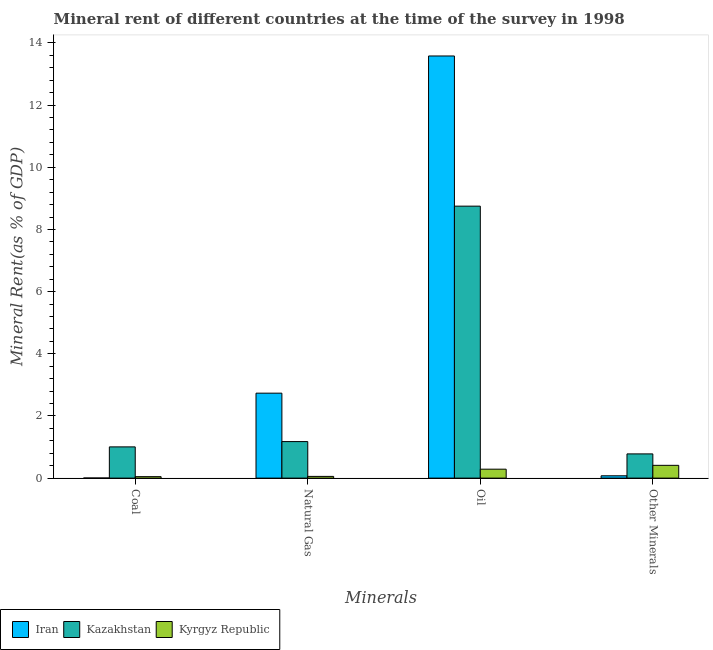How many different coloured bars are there?
Provide a succinct answer. 3. How many groups of bars are there?
Keep it short and to the point. 4. Are the number of bars on each tick of the X-axis equal?
Give a very brief answer. Yes. What is the label of the 1st group of bars from the left?
Make the answer very short. Coal. What is the  rent of other minerals in Kyrgyz Republic?
Offer a terse response. 0.41. Across all countries, what is the maximum natural gas rent?
Offer a very short reply. 2.73. Across all countries, what is the minimum natural gas rent?
Ensure brevity in your answer.  0.06. In which country was the oil rent maximum?
Your answer should be compact. Iran. In which country was the coal rent minimum?
Make the answer very short. Iran. What is the total natural gas rent in the graph?
Your answer should be compact. 3.96. What is the difference between the coal rent in Kazakhstan and that in Kyrgyz Republic?
Offer a very short reply. 0.96. What is the difference between the natural gas rent in Kyrgyz Republic and the coal rent in Iran?
Offer a very short reply. 0.05. What is the average  rent of other minerals per country?
Provide a short and direct response. 0.42. What is the difference between the natural gas rent and coal rent in Iran?
Your answer should be compact. 2.73. In how many countries, is the coal rent greater than 6 %?
Give a very brief answer. 0. What is the ratio of the oil rent in Kazakhstan to that in Iran?
Ensure brevity in your answer.  0.64. Is the difference between the coal rent in Kyrgyz Republic and Kazakhstan greater than the difference between the  rent of other minerals in Kyrgyz Republic and Kazakhstan?
Offer a very short reply. No. What is the difference between the highest and the second highest oil rent?
Your answer should be compact. 4.83. What is the difference between the highest and the lowest  rent of other minerals?
Your response must be concise. 0.7. Is it the case that in every country, the sum of the oil rent and natural gas rent is greater than the sum of  rent of other minerals and coal rent?
Give a very brief answer. No. What does the 1st bar from the left in Coal represents?
Offer a very short reply. Iran. What does the 3rd bar from the right in Oil represents?
Give a very brief answer. Iran. How many bars are there?
Offer a very short reply. 12. Are all the bars in the graph horizontal?
Ensure brevity in your answer.  No. What is the difference between two consecutive major ticks on the Y-axis?
Offer a terse response. 2. Are the values on the major ticks of Y-axis written in scientific E-notation?
Your response must be concise. No. Where does the legend appear in the graph?
Provide a short and direct response. Bottom left. How many legend labels are there?
Provide a succinct answer. 3. What is the title of the graph?
Offer a terse response. Mineral rent of different countries at the time of the survey in 1998. What is the label or title of the X-axis?
Your answer should be compact. Minerals. What is the label or title of the Y-axis?
Ensure brevity in your answer.  Mineral Rent(as % of GDP). What is the Mineral Rent(as % of GDP) in Iran in Coal?
Provide a short and direct response. 0. What is the Mineral Rent(as % of GDP) of Kazakhstan in Coal?
Ensure brevity in your answer.  1.01. What is the Mineral Rent(as % of GDP) in Kyrgyz Republic in Coal?
Your answer should be very brief. 0.05. What is the Mineral Rent(as % of GDP) of Iran in Natural Gas?
Offer a terse response. 2.73. What is the Mineral Rent(as % of GDP) in Kazakhstan in Natural Gas?
Keep it short and to the point. 1.18. What is the Mineral Rent(as % of GDP) in Kyrgyz Republic in Natural Gas?
Offer a very short reply. 0.06. What is the Mineral Rent(as % of GDP) of Iran in Oil?
Offer a very short reply. 13.58. What is the Mineral Rent(as % of GDP) in Kazakhstan in Oil?
Make the answer very short. 8.75. What is the Mineral Rent(as % of GDP) in Kyrgyz Republic in Oil?
Keep it short and to the point. 0.29. What is the Mineral Rent(as % of GDP) in Iran in Other Minerals?
Provide a succinct answer. 0.07. What is the Mineral Rent(as % of GDP) in Kazakhstan in Other Minerals?
Offer a terse response. 0.78. What is the Mineral Rent(as % of GDP) in Kyrgyz Republic in Other Minerals?
Your answer should be very brief. 0.41. Across all Minerals, what is the maximum Mineral Rent(as % of GDP) in Iran?
Keep it short and to the point. 13.58. Across all Minerals, what is the maximum Mineral Rent(as % of GDP) of Kazakhstan?
Offer a terse response. 8.75. Across all Minerals, what is the maximum Mineral Rent(as % of GDP) of Kyrgyz Republic?
Give a very brief answer. 0.41. Across all Minerals, what is the minimum Mineral Rent(as % of GDP) of Iran?
Make the answer very short. 0. Across all Minerals, what is the minimum Mineral Rent(as % of GDP) of Kazakhstan?
Your answer should be compact. 0.78. Across all Minerals, what is the minimum Mineral Rent(as % of GDP) in Kyrgyz Republic?
Make the answer very short. 0.05. What is the total Mineral Rent(as % of GDP) of Iran in the graph?
Give a very brief answer. 16.39. What is the total Mineral Rent(as % of GDP) of Kazakhstan in the graph?
Ensure brevity in your answer.  11.71. What is the total Mineral Rent(as % of GDP) of Kyrgyz Republic in the graph?
Your answer should be very brief. 0.8. What is the difference between the Mineral Rent(as % of GDP) in Iran in Coal and that in Natural Gas?
Provide a succinct answer. -2.73. What is the difference between the Mineral Rent(as % of GDP) in Kazakhstan in Coal and that in Natural Gas?
Ensure brevity in your answer.  -0.17. What is the difference between the Mineral Rent(as % of GDP) in Kyrgyz Republic in Coal and that in Natural Gas?
Ensure brevity in your answer.  -0.01. What is the difference between the Mineral Rent(as % of GDP) in Iran in Coal and that in Oil?
Your answer should be very brief. -13.58. What is the difference between the Mineral Rent(as % of GDP) in Kazakhstan in Coal and that in Oil?
Provide a short and direct response. -7.75. What is the difference between the Mineral Rent(as % of GDP) of Kyrgyz Republic in Coal and that in Oil?
Ensure brevity in your answer.  -0.24. What is the difference between the Mineral Rent(as % of GDP) of Iran in Coal and that in Other Minerals?
Your response must be concise. -0.07. What is the difference between the Mineral Rent(as % of GDP) in Kazakhstan in Coal and that in Other Minerals?
Provide a succinct answer. 0.23. What is the difference between the Mineral Rent(as % of GDP) of Kyrgyz Republic in Coal and that in Other Minerals?
Make the answer very short. -0.36. What is the difference between the Mineral Rent(as % of GDP) of Iran in Natural Gas and that in Oil?
Your response must be concise. -10.85. What is the difference between the Mineral Rent(as % of GDP) of Kazakhstan in Natural Gas and that in Oil?
Ensure brevity in your answer.  -7.57. What is the difference between the Mineral Rent(as % of GDP) of Kyrgyz Republic in Natural Gas and that in Oil?
Your response must be concise. -0.23. What is the difference between the Mineral Rent(as % of GDP) of Iran in Natural Gas and that in Other Minerals?
Keep it short and to the point. 2.66. What is the difference between the Mineral Rent(as % of GDP) in Kazakhstan in Natural Gas and that in Other Minerals?
Your answer should be very brief. 0.4. What is the difference between the Mineral Rent(as % of GDP) of Kyrgyz Republic in Natural Gas and that in Other Minerals?
Provide a short and direct response. -0.36. What is the difference between the Mineral Rent(as % of GDP) of Iran in Oil and that in Other Minerals?
Your response must be concise. 13.51. What is the difference between the Mineral Rent(as % of GDP) in Kazakhstan in Oil and that in Other Minerals?
Give a very brief answer. 7.97. What is the difference between the Mineral Rent(as % of GDP) in Kyrgyz Republic in Oil and that in Other Minerals?
Offer a terse response. -0.12. What is the difference between the Mineral Rent(as % of GDP) in Iran in Coal and the Mineral Rent(as % of GDP) in Kazakhstan in Natural Gas?
Ensure brevity in your answer.  -1.17. What is the difference between the Mineral Rent(as % of GDP) in Iran in Coal and the Mineral Rent(as % of GDP) in Kyrgyz Republic in Natural Gas?
Keep it short and to the point. -0.05. What is the difference between the Mineral Rent(as % of GDP) of Kazakhstan in Coal and the Mineral Rent(as % of GDP) of Kyrgyz Republic in Natural Gas?
Keep it short and to the point. 0.95. What is the difference between the Mineral Rent(as % of GDP) in Iran in Coal and the Mineral Rent(as % of GDP) in Kazakhstan in Oil?
Offer a terse response. -8.75. What is the difference between the Mineral Rent(as % of GDP) of Iran in Coal and the Mineral Rent(as % of GDP) of Kyrgyz Republic in Oil?
Keep it short and to the point. -0.28. What is the difference between the Mineral Rent(as % of GDP) of Kazakhstan in Coal and the Mineral Rent(as % of GDP) of Kyrgyz Republic in Oil?
Provide a succinct answer. 0.72. What is the difference between the Mineral Rent(as % of GDP) of Iran in Coal and the Mineral Rent(as % of GDP) of Kazakhstan in Other Minerals?
Your response must be concise. -0.78. What is the difference between the Mineral Rent(as % of GDP) in Iran in Coal and the Mineral Rent(as % of GDP) in Kyrgyz Republic in Other Minerals?
Your answer should be compact. -0.41. What is the difference between the Mineral Rent(as % of GDP) of Kazakhstan in Coal and the Mineral Rent(as % of GDP) of Kyrgyz Republic in Other Minerals?
Provide a short and direct response. 0.59. What is the difference between the Mineral Rent(as % of GDP) in Iran in Natural Gas and the Mineral Rent(as % of GDP) in Kazakhstan in Oil?
Offer a very short reply. -6.02. What is the difference between the Mineral Rent(as % of GDP) in Iran in Natural Gas and the Mineral Rent(as % of GDP) in Kyrgyz Republic in Oil?
Your answer should be compact. 2.45. What is the difference between the Mineral Rent(as % of GDP) of Kazakhstan in Natural Gas and the Mineral Rent(as % of GDP) of Kyrgyz Republic in Oil?
Keep it short and to the point. 0.89. What is the difference between the Mineral Rent(as % of GDP) of Iran in Natural Gas and the Mineral Rent(as % of GDP) of Kazakhstan in Other Minerals?
Provide a succinct answer. 1.95. What is the difference between the Mineral Rent(as % of GDP) in Iran in Natural Gas and the Mineral Rent(as % of GDP) in Kyrgyz Republic in Other Minerals?
Give a very brief answer. 2.32. What is the difference between the Mineral Rent(as % of GDP) in Kazakhstan in Natural Gas and the Mineral Rent(as % of GDP) in Kyrgyz Republic in Other Minerals?
Provide a succinct answer. 0.76. What is the difference between the Mineral Rent(as % of GDP) in Iran in Oil and the Mineral Rent(as % of GDP) in Kazakhstan in Other Minerals?
Offer a very short reply. 12.8. What is the difference between the Mineral Rent(as % of GDP) of Iran in Oil and the Mineral Rent(as % of GDP) of Kyrgyz Republic in Other Minerals?
Provide a succinct answer. 13.17. What is the difference between the Mineral Rent(as % of GDP) of Kazakhstan in Oil and the Mineral Rent(as % of GDP) of Kyrgyz Republic in Other Minerals?
Make the answer very short. 8.34. What is the average Mineral Rent(as % of GDP) of Iran per Minerals?
Provide a short and direct response. 4.1. What is the average Mineral Rent(as % of GDP) in Kazakhstan per Minerals?
Provide a short and direct response. 2.93. What is the average Mineral Rent(as % of GDP) in Kyrgyz Republic per Minerals?
Make the answer very short. 0.2. What is the difference between the Mineral Rent(as % of GDP) in Iran and Mineral Rent(as % of GDP) in Kazakhstan in Coal?
Your answer should be compact. -1. What is the difference between the Mineral Rent(as % of GDP) in Iran and Mineral Rent(as % of GDP) in Kyrgyz Republic in Coal?
Your answer should be very brief. -0.04. What is the difference between the Mineral Rent(as % of GDP) of Kazakhstan and Mineral Rent(as % of GDP) of Kyrgyz Republic in Coal?
Your response must be concise. 0.96. What is the difference between the Mineral Rent(as % of GDP) in Iran and Mineral Rent(as % of GDP) in Kazakhstan in Natural Gas?
Your answer should be compact. 1.56. What is the difference between the Mineral Rent(as % of GDP) in Iran and Mineral Rent(as % of GDP) in Kyrgyz Republic in Natural Gas?
Offer a very short reply. 2.68. What is the difference between the Mineral Rent(as % of GDP) of Kazakhstan and Mineral Rent(as % of GDP) of Kyrgyz Republic in Natural Gas?
Your response must be concise. 1.12. What is the difference between the Mineral Rent(as % of GDP) in Iran and Mineral Rent(as % of GDP) in Kazakhstan in Oil?
Your response must be concise. 4.83. What is the difference between the Mineral Rent(as % of GDP) in Iran and Mineral Rent(as % of GDP) in Kyrgyz Republic in Oil?
Provide a succinct answer. 13.29. What is the difference between the Mineral Rent(as % of GDP) of Kazakhstan and Mineral Rent(as % of GDP) of Kyrgyz Republic in Oil?
Give a very brief answer. 8.46. What is the difference between the Mineral Rent(as % of GDP) of Iran and Mineral Rent(as % of GDP) of Kazakhstan in Other Minerals?
Ensure brevity in your answer.  -0.7. What is the difference between the Mineral Rent(as % of GDP) in Iran and Mineral Rent(as % of GDP) in Kyrgyz Republic in Other Minerals?
Give a very brief answer. -0.34. What is the difference between the Mineral Rent(as % of GDP) in Kazakhstan and Mineral Rent(as % of GDP) in Kyrgyz Republic in Other Minerals?
Provide a succinct answer. 0.37. What is the ratio of the Mineral Rent(as % of GDP) of Iran in Coal to that in Natural Gas?
Give a very brief answer. 0. What is the ratio of the Mineral Rent(as % of GDP) in Kazakhstan in Coal to that in Natural Gas?
Provide a short and direct response. 0.86. What is the ratio of the Mineral Rent(as % of GDP) of Kyrgyz Republic in Coal to that in Natural Gas?
Keep it short and to the point. 0.85. What is the ratio of the Mineral Rent(as % of GDP) of Iran in Coal to that in Oil?
Your answer should be compact. 0. What is the ratio of the Mineral Rent(as % of GDP) of Kazakhstan in Coal to that in Oil?
Make the answer very short. 0.11. What is the ratio of the Mineral Rent(as % of GDP) in Kyrgyz Republic in Coal to that in Oil?
Keep it short and to the point. 0.16. What is the ratio of the Mineral Rent(as % of GDP) in Iran in Coal to that in Other Minerals?
Ensure brevity in your answer.  0.05. What is the ratio of the Mineral Rent(as % of GDP) of Kazakhstan in Coal to that in Other Minerals?
Offer a terse response. 1.29. What is the ratio of the Mineral Rent(as % of GDP) in Kyrgyz Republic in Coal to that in Other Minerals?
Keep it short and to the point. 0.11. What is the ratio of the Mineral Rent(as % of GDP) in Iran in Natural Gas to that in Oil?
Your answer should be compact. 0.2. What is the ratio of the Mineral Rent(as % of GDP) in Kazakhstan in Natural Gas to that in Oil?
Make the answer very short. 0.13. What is the ratio of the Mineral Rent(as % of GDP) in Kyrgyz Republic in Natural Gas to that in Oil?
Make the answer very short. 0.19. What is the ratio of the Mineral Rent(as % of GDP) in Iran in Natural Gas to that in Other Minerals?
Offer a terse response. 36.59. What is the ratio of the Mineral Rent(as % of GDP) of Kazakhstan in Natural Gas to that in Other Minerals?
Provide a short and direct response. 1.51. What is the ratio of the Mineral Rent(as % of GDP) of Kyrgyz Republic in Natural Gas to that in Other Minerals?
Provide a short and direct response. 0.14. What is the ratio of the Mineral Rent(as % of GDP) in Iran in Oil to that in Other Minerals?
Give a very brief answer. 181.81. What is the ratio of the Mineral Rent(as % of GDP) in Kazakhstan in Oil to that in Other Minerals?
Provide a short and direct response. 11.23. What is the ratio of the Mineral Rent(as % of GDP) in Kyrgyz Republic in Oil to that in Other Minerals?
Ensure brevity in your answer.  0.7. What is the difference between the highest and the second highest Mineral Rent(as % of GDP) of Iran?
Offer a terse response. 10.85. What is the difference between the highest and the second highest Mineral Rent(as % of GDP) in Kazakhstan?
Make the answer very short. 7.57. What is the difference between the highest and the second highest Mineral Rent(as % of GDP) in Kyrgyz Republic?
Offer a terse response. 0.12. What is the difference between the highest and the lowest Mineral Rent(as % of GDP) of Iran?
Your answer should be very brief. 13.58. What is the difference between the highest and the lowest Mineral Rent(as % of GDP) of Kazakhstan?
Keep it short and to the point. 7.97. What is the difference between the highest and the lowest Mineral Rent(as % of GDP) of Kyrgyz Republic?
Your answer should be compact. 0.36. 